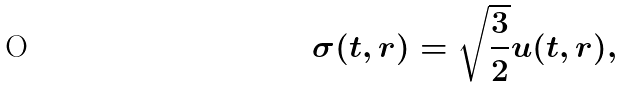<formula> <loc_0><loc_0><loc_500><loc_500>\sigma ( t , r ) = \sqrt { \frac { 3 } { 2 } } u ( t , r ) ,</formula> 